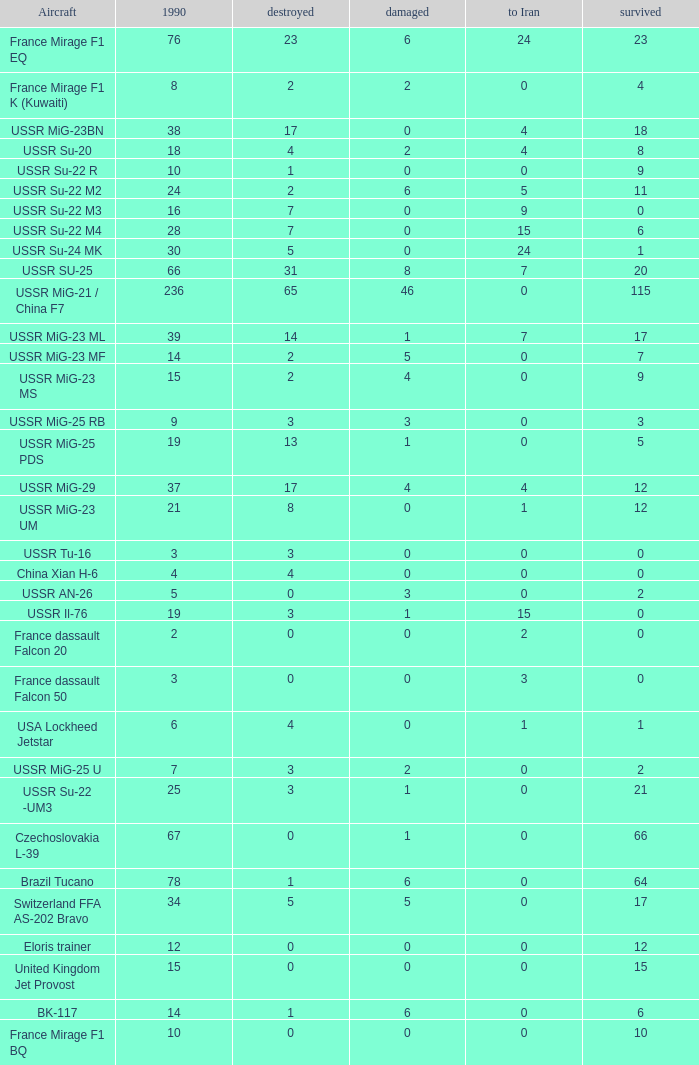Out of the 14 present in 1990, with 6 remaining, how many were lost? 1.0. 